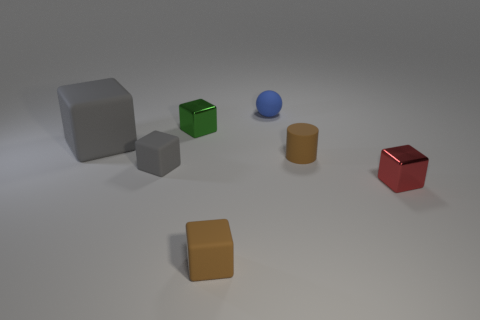How many other objects have the same shape as the small red thing?
Give a very brief answer. 4. There is a small red object that is the same material as the small green block; what shape is it?
Provide a succinct answer. Cube. How many gray things are either small matte cylinders or rubber objects?
Give a very brief answer. 2. Are there any tiny rubber objects in front of the small cylinder?
Provide a succinct answer. Yes. There is a metallic thing that is on the left side of the small red cube; is its shape the same as the small rubber object behind the tiny green thing?
Offer a very short reply. No. There is a tiny brown object that is the same shape as the large gray thing; what is it made of?
Give a very brief answer. Rubber. What number of cubes are gray rubber objects or small blue rubber things?
Offer a very short reply. 2. How many green cubes are made of the same material as the tiny red block?
Your response must be concise. 1. Are the small cube to the left of the green shiny thing and the block in front of the red thing made of the same material?
Your answer should be very brief. Yes. There is a tiny brown rubber object on the left side of the blue object that is behind the big gray rubber block; what number of metal cubes are to the right of it?
Keep it short and to the point. 1. 